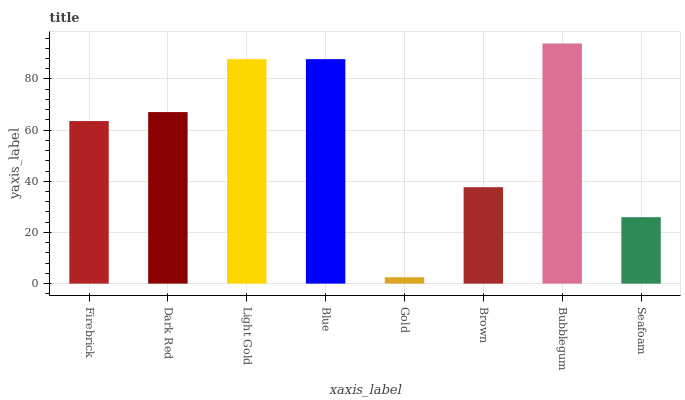Is Gold the minimum?
Answer yes or no. Yes. Is Bubblegum the maximum?
Answer yes or no. Yes. Is Dark Red the minimum?
Answer yes or no. No. Is Dark Red the maximum?
Answer yes or no. No. Is Dark Red greater than Firebrick?
Answer yes or no. Yes. Is Firebrick less than Dark Red?
Answer yes or no. Yes. Is Firebrick greater than Dark Red?
Answer yes or no. No. Is Dark Red less than Firebrick?
Answer yes or no. No. Is Dark Red the high median?
Answer yes or no. Yes. Is Firebrick the low median?
Answer yes or no. Yes. Is Bubblegum the high median?
Answer yes or no. No. Is Dark Red the low median?
Answer yes or no. No. 